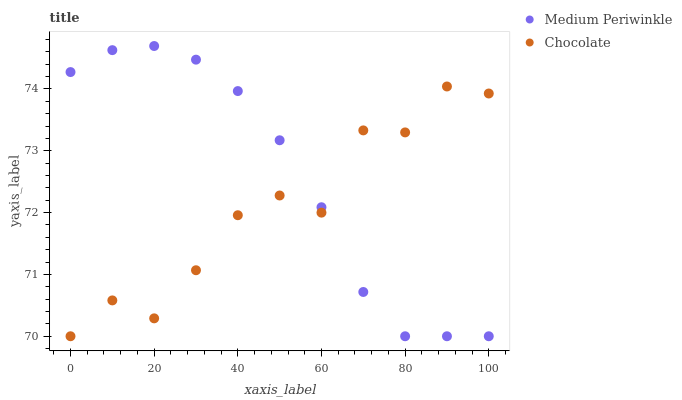Does Chocolate have the minimum area under the curve?
Answer yes or no. Yes. Does Medium Periwinkle have the maximum area under the curve?
Answer yes or no. Yes. Does Chocolate have the maximum area under the curve?
Answer yes or no. No. Is Medium Periwinkle the smoothest?
Answer yes or no. Yes. Is Chocolate the roughest?
Answer yes or no. Yes. Is Chocolate the smoothest?
Answer yes or no. No. Does Medium Periwinkle have the lowest value?
Answer yes or no. Yes. Does Medium Periwinkle have the highest value?
Answer yes or no. Yes. Does Chocolate have the highest value?
Answer yes or no. No. Does Chocolate intersect Medium Periwinkle?
Answer yes or no. Yes. Is Chocolate less than Medium Periwinkle?
Answer yes or no. No. Is Chocolate greater than Medium Periwinkle?
Answer yes or no. No. 